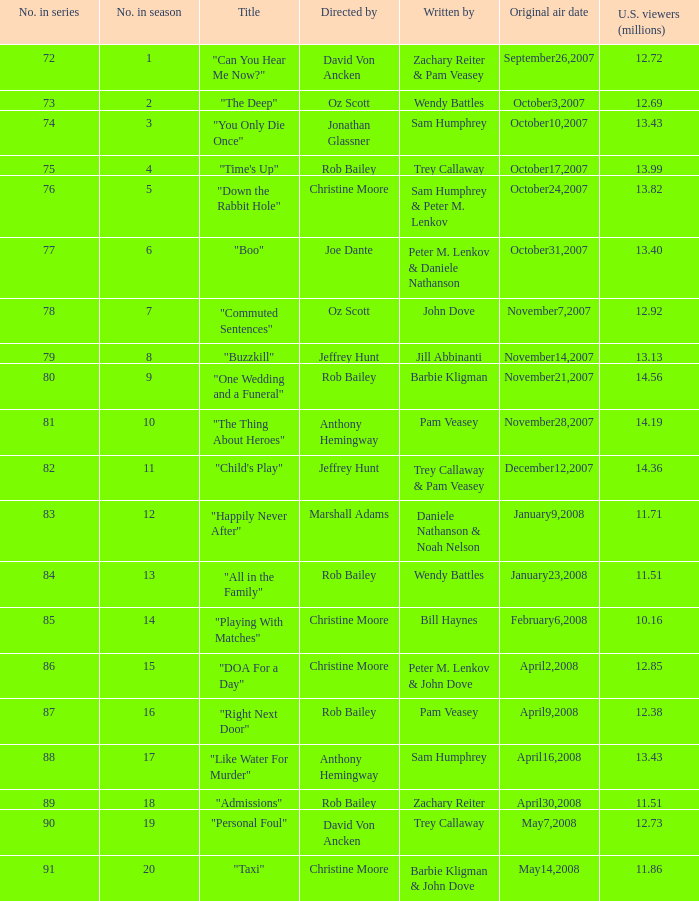How many millions of U.S. viewers watched the episode directed by Rob Bailey and written by Pam Veasey? 12.38. 